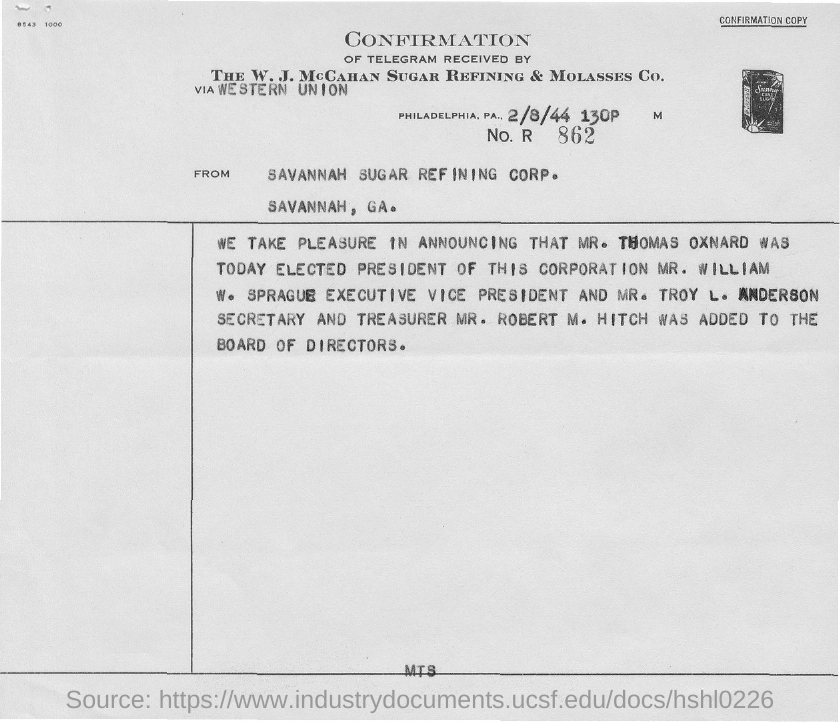Who was elected President of the Corporation?
Offer a very short reply. Mr. Thomas Oxnard. Who was elected the Executive vice president?
Your answer should be compact. Mr. William W. Sprague. Who is  the secreatry?
Your answer should be compact. Mr. Troy L. Anderson. Who is the Treasurer?
Your response must be concise. Mr. Robert M. Hitch. What is the date on the document?
Your answer should be very brief. 2/8/44. 